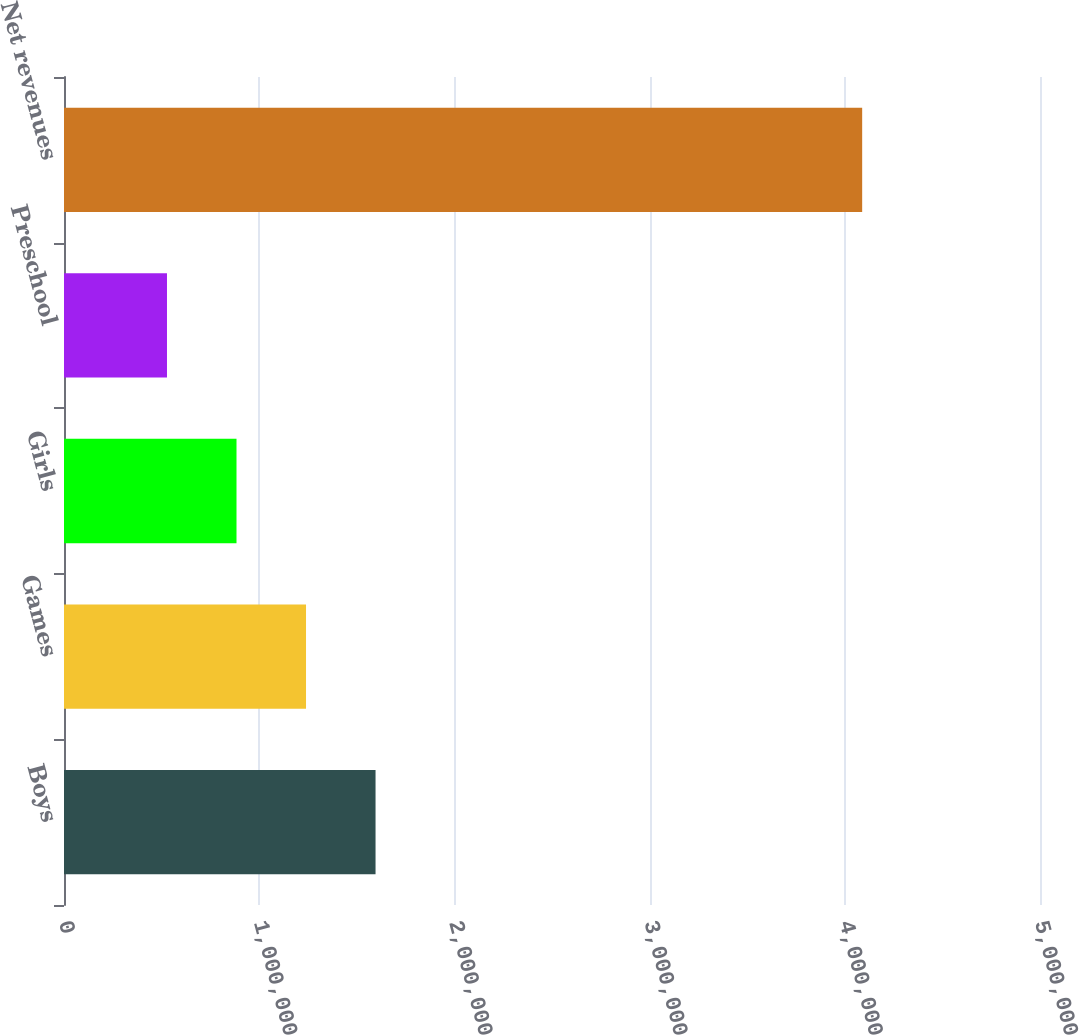Convert chart. <chart><loc_0><loc_0><loc_500><loc_500><bar_chart><fcel>Boys<fcel>Games<fcel>Girls<fcel>Preschool<fcel>Net revenues<nl><fcel>1.59601e+06<fcel>1.23987e+06<fcel>883730<fcel>527591<fcel>4.08898e+06<nl></chart> 